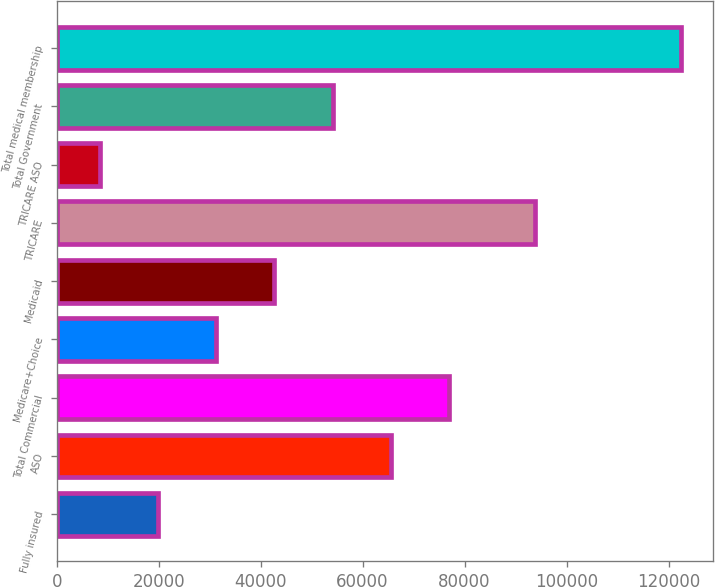Convert chart to OTSL. <chart><loc_0><loc_0><loc_500><loc_500><bar_chart><fcel>Fully insured<fcel>ASO<fcel>Total Commercial<fcel>Medicare+Choice<fcel>Medicaid<fcel>TRICARE<fcel>TRICARE ASO<fcel>Total Government<fcel>Total medical membership<nl><fcel>19900<fcel>65500<fcel>76900<fcel>31300<fcel>42700<fcel>93900<fcel>8500<fcel>54100<fcel>122500<nl></chart> 